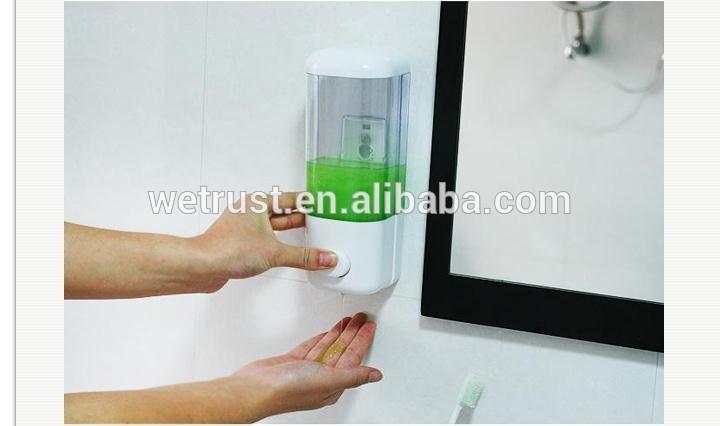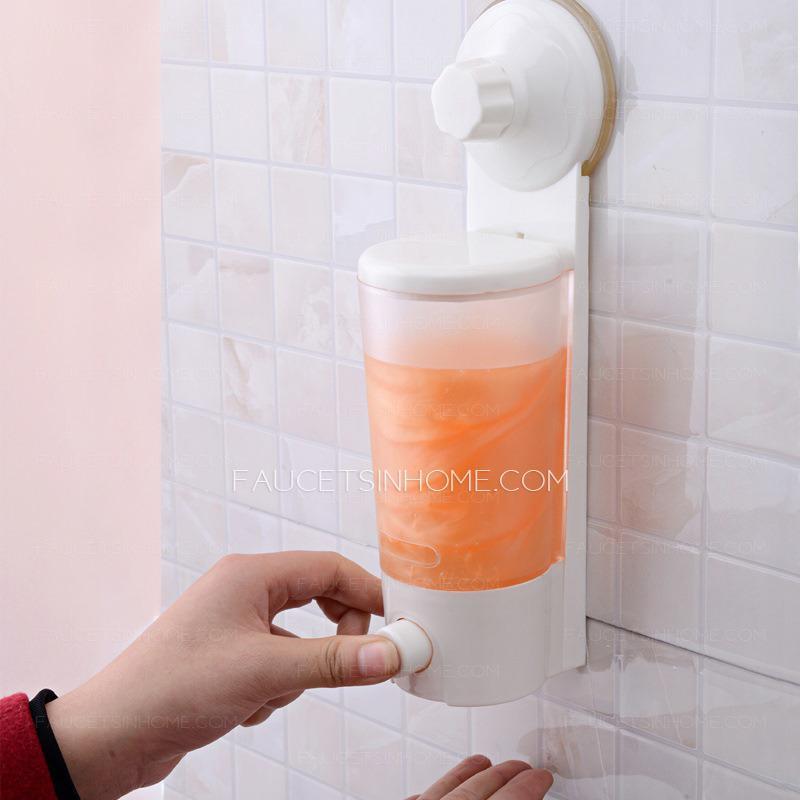The first image is the image on the left, the second image is the image on the right. Analyze the images presented: Is the assertion "One of these is silver in color." valid? Answer yes or no. No. The first image is the image on the left, the second image is the image on the right. Assess this claim about the two images: "An image features a cylindrical dispenser with chrome finish.". Correct or not? Answer yes or no. No. 